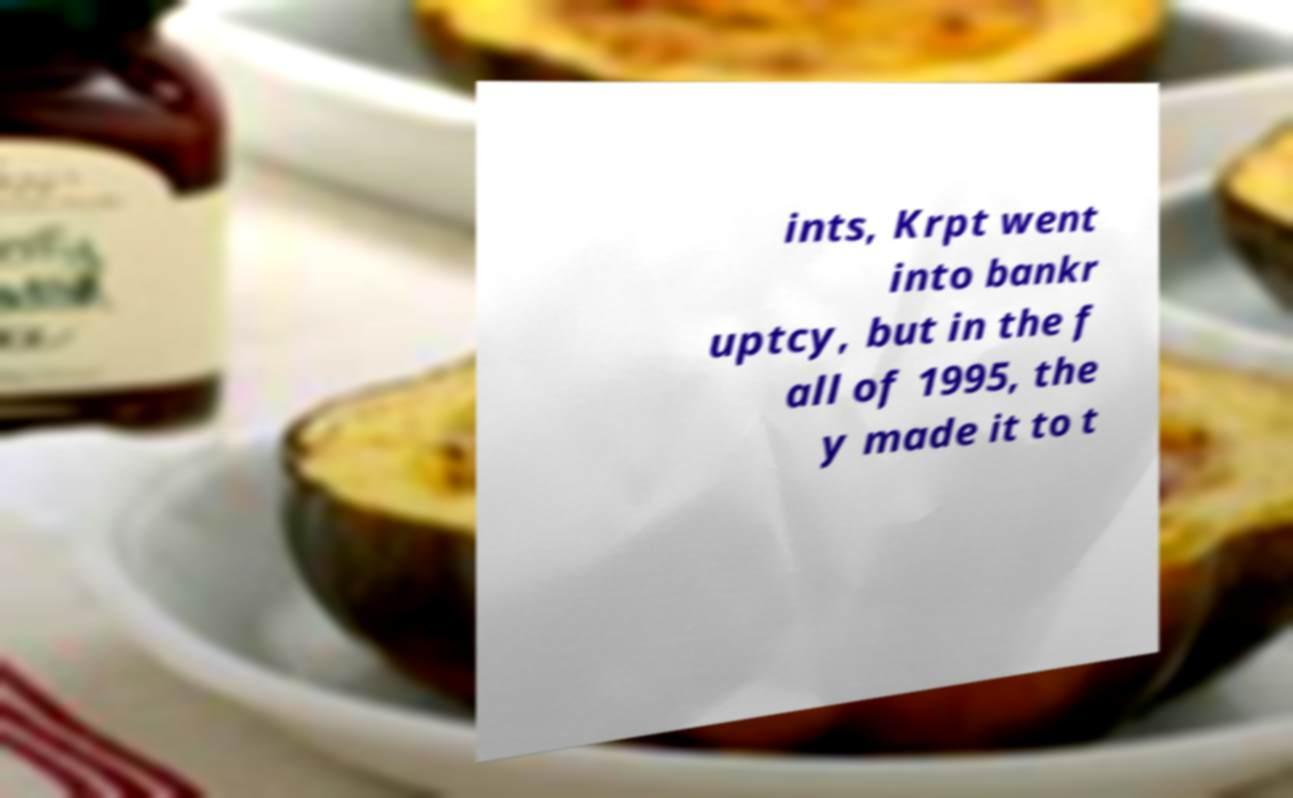I need the written content from this picture converted into text. Can you do that? ints, Krpt went into bankr uptcy, but in the f all of 1995, the y made it to t 